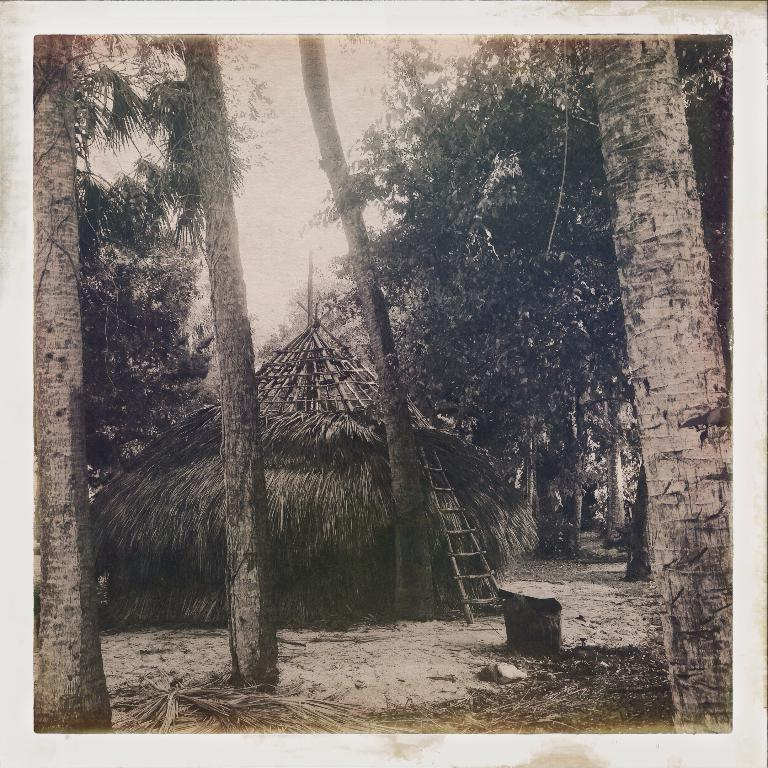What is the color scheme of the image? The image is black and white. What type of vegetation is visible in the image? There are coconut trees in the front of the image. What type of structure is present in the image? There is a hut in the image. What feature is present in front of the hut? The hut has a ladder in front of it. What religious symbols can be seen on the street in the image? There is no street present in the image, and no religious symbols are visible. 